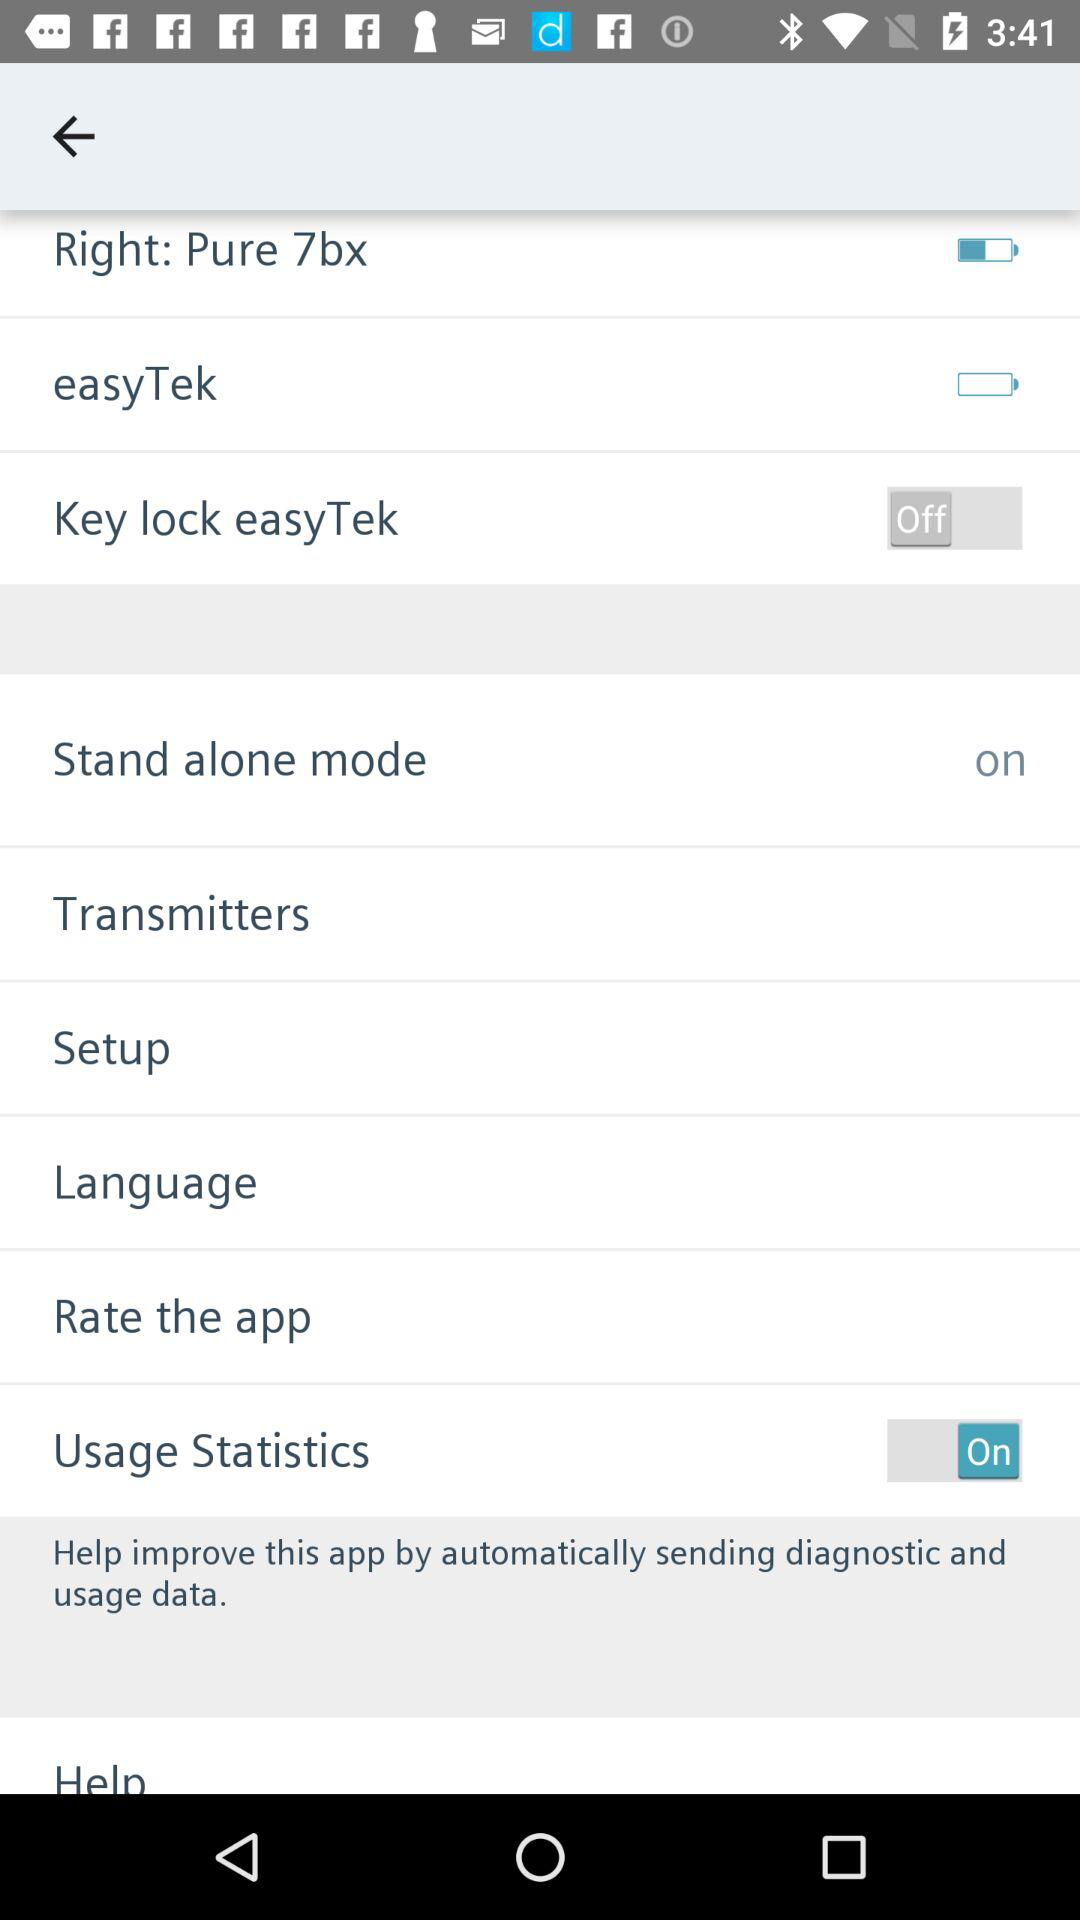What is the status of "Usage Statistics"? "Usage Statistics" is turned on. 